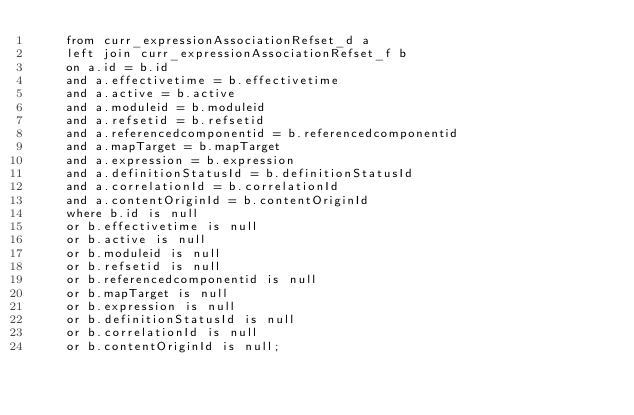<code> <loc_0><loc_0><loc_500><loc_500><_SQL_>	from curr_expressionAssociationRefset_d a
	left join curr_expressionAssociationRefset_f b
	on a.id = b.id
	and a.effectivetime = b.effectivetime
	and a.active = b.active
	and a.moduleid = b.moduleid
	and a.refsetid = b.refsetid
	and a.referencedcomponentid = b.referencedcomponentid
	and a.mapTarget = b.mapTarget
	and a.expression = b.expression
	and a.definitionStatusId = b.definitionStatusId
	and a.correlationId = b.correlationId
	and a.contentOriginId = b.contentOriginId
	where b.id is null
	or b.effectivetime is null
	or b.active is null
	or b.moduleid is null
	or b.refsetid is null
	or b.referencedcomponentid is null
	or b.mapTarget is null
	or b.expression is null
	or b.definitionStatusId is null
	or b.correlationId is null
	or b.contentOriginId is null;</code> 